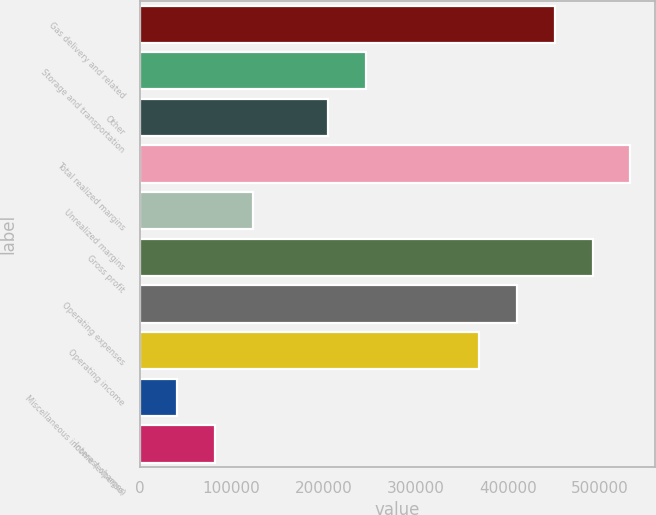<chart> <loc_0><loc_0><loc_500><loc_500><bar_chart><fcel>Gas delivery and related<fcel>Storage and transportation<fcel>Other<fcel>Total realized margins<fcel>Unrealized margins<fcel>Gross profit<fcel>Operating expenses<fcel>Operating income<fcel>Miscellaneous income (expense)<fcel>Interest charges<nl><fcel>451047<fcel>246032<fcel>205029<fcel>533053<fcel>123023<fcel>492050<fcel>410044<fcel>369041<fcel>41017.5<fcel>82020.5<nl></chart> 